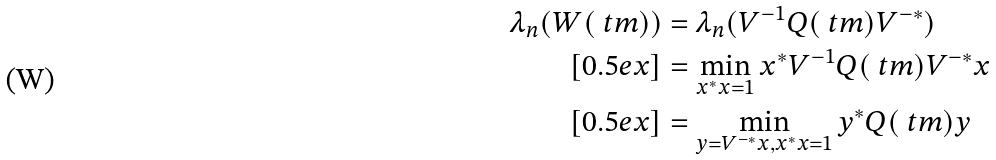<formula> <loc_0><loc_0><loc_500><loc_500>\lambda _ { n } ( W ( \ t m ) ) & = \lambda _ { n } ( V ^ { - 1 } Q ( \ t m ) V ^ { - * } ) \\ [ 0 . 5 e x ] & = \min _ { x ^ { * } x = 1 } x ^ { * } V ^ { - 1 } Q ( \ t m ) V ^ { - * } x \\ [ 0 . 5 e x ] & = \min _ { y = V ^ { - * } x , x ^ { * } x = 1 } y ^ { * } Q ( \ t m ) y</formula> 